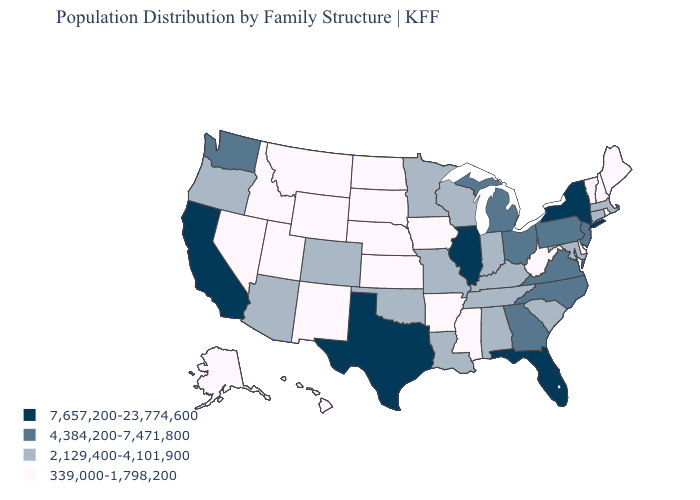Name the states that have a value in the range 7,657,200-23,774,600?
Give a very brief answer. California, Florida, Illinois, New York, Texas. Does the first symbol in the legend represent the smallest category?
Give a very brief answer. No. Which states have the lowest value in the Northeast?
Write a very short answer. Maine, New Hampshire, Rhode Island, Vermont. Is the legend a continuous bar?
Quick response, please. No. Name the states that have a value in the range 339,000-1,798,200?
Write a very short answer. Alaska, Arkansas, Delaware, Hawaii, Idaho, Iowa, Kansas, Maine, Mississippi, Montana, Nebraska, Nevada, New Hampshire, New Mexico, North Dakota, Rhode Island, South Dakota, Utah, Vermont, West Virginia, Wyoming. Does Montana have the lowest value in the West?
Give a very brief answer. Yes. Name the states that have a value in the range 4,384,200-7,471,800?
Be succinct. Georgia, Michigan, New Jersey, North Carolina, Ohio, Pennsylvania, Virginia, Washington. What is the value of Arizona?
Answer briefly. 2,129,400-4,101,900. What is the highest value in the USA?
Short answer required. 7,657,200-23,774,600. Does the map have missing data?
Be succinct. No. Name the states that have a value in the range 4,384,200-7,471,800?
Quick response, please. Georgia, Michigan, New Jersey, North Carolina, Ohio, Pennsylvania, Virginia, Washington. What is the value of Wisconsin?
Short answer required. 2,129,400-4,101,900. What is the value of Alaska?
Write a very short answer. 339,000-1,798,200. Which states have the lowest value in the USA?
Quick response, please. Alaska, Arkansas, Delaware, Hawaii, Idaho, Iowa, Kansas, Maine, Mississippi, Montana, Nebraska, Nevada, New Hampshire, New Mexico, North Dakota, Rhode Island, South Dakota, Utah, Vermont, West Virginia, Wyoming. What is the value of Oregon?
Write a very short answer. 2,129,400-4,101,900. 